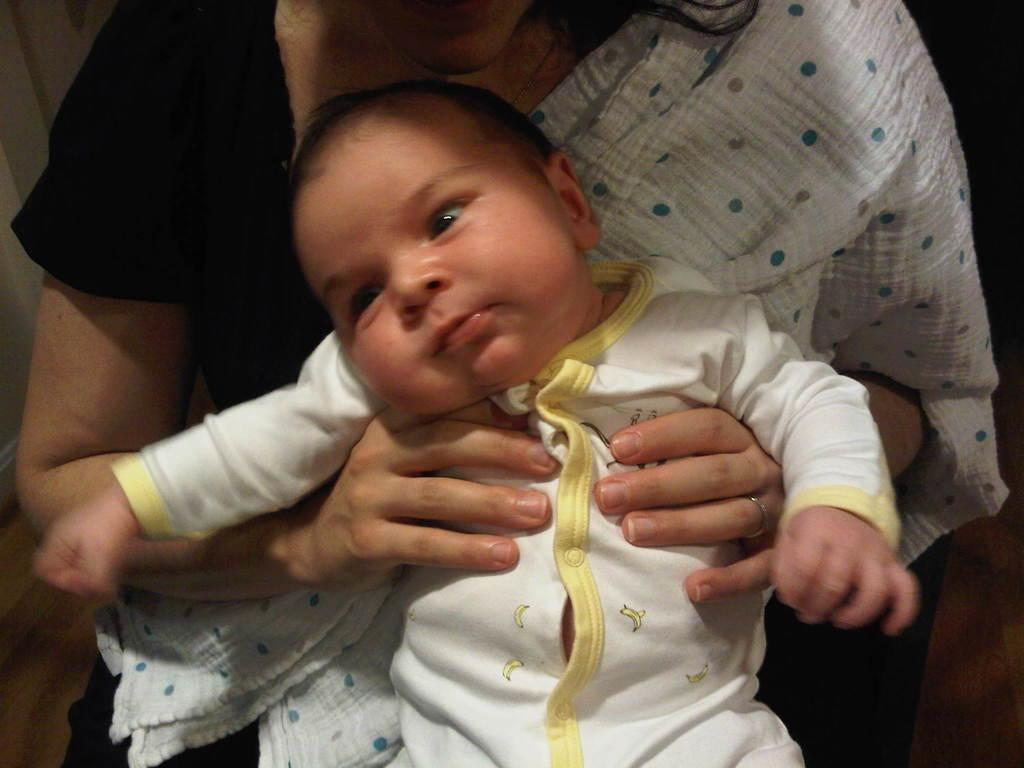Who is the main subject in the image? There is a woman in the image. What is the woman doing in the image? The woman is holding a baby. What can be seen in the background of the image? There is a wall visible in the background of the image. What is the surface on which the woman and baby are standing? There is a floor visible in the image. What is the texture of the baby's clothing in the image? The texture of the baby's clothing cannot be determined from the image, as it is not detailed enough to provide that information. 